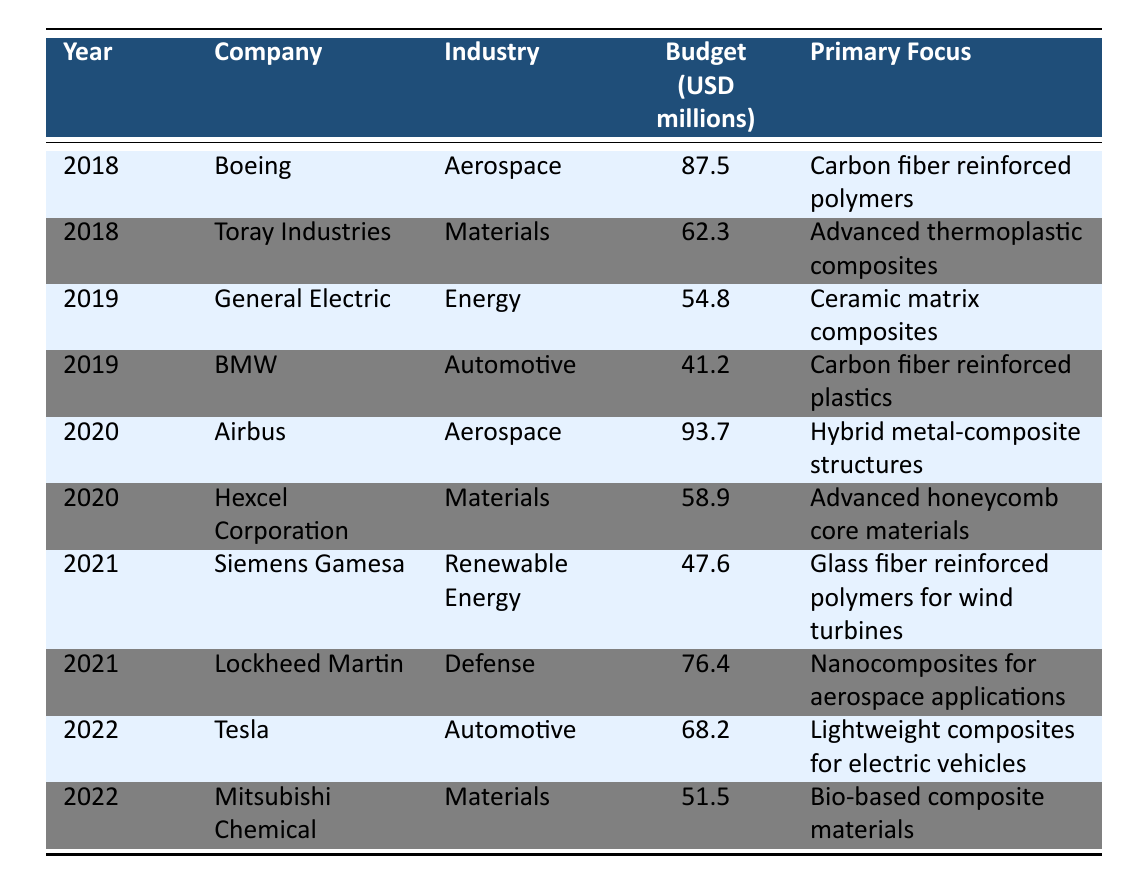What was the total budget allocated for composite material projects in 2020? The budget for 2020 consists of two entries: Airbus with 93.7 million and Hexcel Corporation with 58.9 million. Adding these gives us 93.7 + 58.9 = 152.6 million.
Answer: 152.6 million Which company had the highest budget in 2019? The entries for 2019 are General Electric with 54.8 million and BMW with 41.2 million. General Electric has the higher budget.
Answer: General Electric Was there a company that focused on bio-based composite materials in any year? The table lists Mitsubishi Chemical in 2022, with a focus on bio-based composite materials. Thus, the statement is true.
Answer: Yes What is the average budget allocated to composite material projects from 2018 to 2022? The budgets across the years from the table are: 87.5 (2018), 62.3 (2018), 54.8 (2019), 41.2 (2019), 93.7 (2020), 58.9 (2020), 47.6 (2021), 76.4 (2021), 68.2 (2022), 51.5 (2022). Adding these gives 524.6 million and dividing by 10 (the number of entries) results in an average of 52.46 million.
Answer: 52.46 million Which industry had the lowest budget in 2021? In 2021, Siemens Gamesa allocated 47.6 million and Lockheed Martin allocated 76.4 million. Therefore, Siemens Gamesa had the lowest budget in that year.
Answer: Siemens Gamesa What trend can be observed regarding the aerospace industry's budget from 2018 to 2020? The aerospace industry had budgets of 87.5 million in 2018 (Boeing), and 93.7 million in 2020 (Airbus). There is an increase over the years as Boeing's budget is lower than Airbus's.
Answer: Increasing trend In which year did the materials industry see the highest budget allocation? The materials industry had budgets of 62.3 million in 2018 (Toray Industries) and 58.9 million in 2020 (Hexcel Corporation). The highest budget for this industry is from 2018.
Answer: 2018 How many companies focused on automotive applications between 2018 and 2022? The table shows BMW in 2019 and Tesla in 2022 focusing on automotive applications, making a total of 2.
Answer: 2 Is there a company that focused on carbon fiber reinforced polymers in 2018? Yes, Boeing had a budget of 87.5 million in 2018 with a primary focus on carbon fiber reinforced polymers.
Answer: Yes What was the combined budget for the materials industry in 2018 and 2022? The materials industry had budgets of 62.3 million in 2018 (Toray Industries) and 51.5 million in 2022 (Mitsubishi Chemical). Adding these budgets results in 62.3 + 51.5 = 113.8 million.
Answer: 113.8 million 